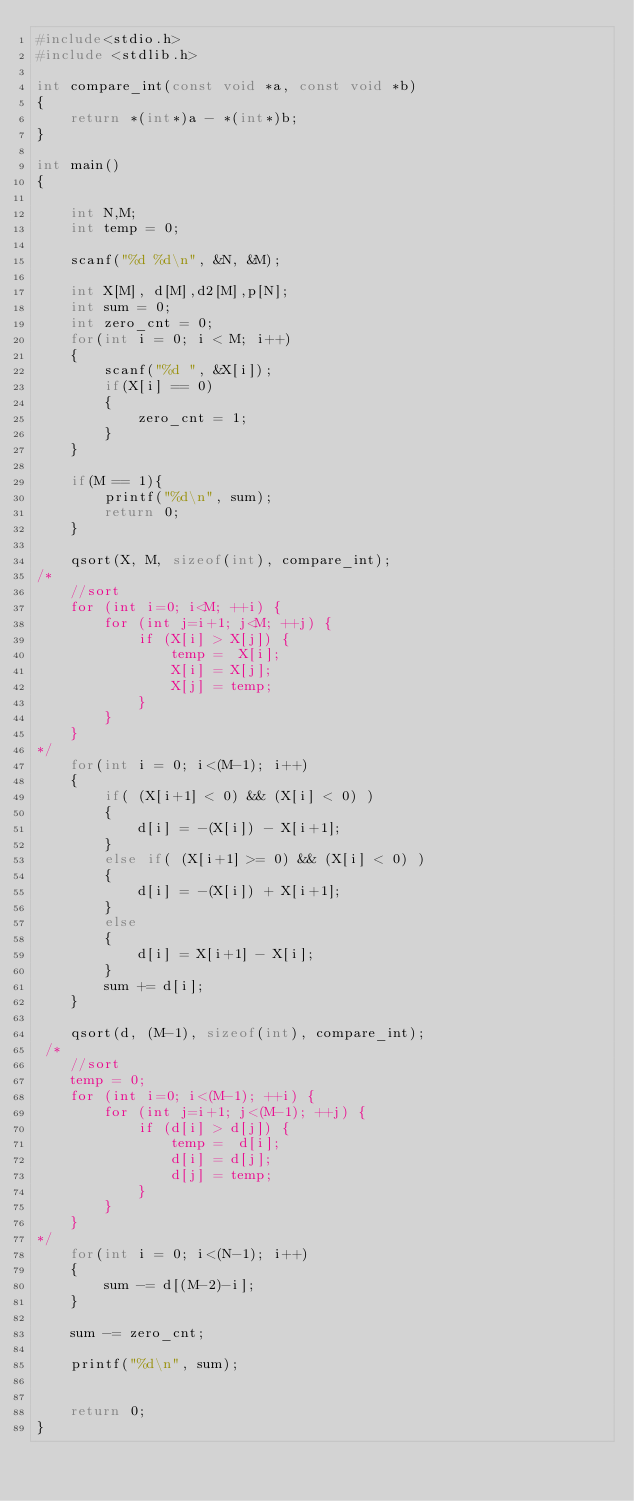<code> <loc_0><loc_0><loc_500><loc_500><_C_>#include<stdio.h>
#include <stdlib.h>

int compare_int(const void *a, const void *b)
{
    return *(int*)a - *(int*)b;
}

int main()
{

    int N,M;
    int temp = 0;

    scanf("%d %d\n", &N, &M);

    int X[M], d[M],d2[M],p[N];
    int sum = 0;
    int zero_cnt = 0;
    for(int i = 0; i < M; i++)
    {
        scanf("%d ", &X[i]);
        if(X[i] == 0)
        {
            zero_cnt = 1;
        }
    }

    if(M == 1){
        printf("%d\n", sum);
        return 0;
    }

    qsort(X, M, sizeof(int), compare_int);
/*
    //sort
    for (int i=0; i<M; ++i) {
        for (int j=i+1; j<M; ++j) {
            if (X[i] > X[j]) {
                temp =  X[i];
                X[i] = X[j];
                X[j] = temp;
            }
        }
    }
*/
    for(int i = 0; i<(M-1); i++)
    {
        if( (X[i+1] < 0) && (X[i] < 0) )
        {
            d[i] = -(X[i]) - X[i+1];
        }
        else if( (X[i+1] >= 0) && (X[i] < 0) )
        {
            d[i] = -(X[i]) + X[i+1];
        }
        else
        {
            d[i] = X[i+1] - X[i];
        }
        sum += d[i];        
    }

    qsort(d, (M-1), sizeof(int), compare_int);
 /*   
    //sort
    temp = 0;
    for (int i=0; i<(M-1); ++i) {
        for (int j=i+1; j<(M-1); ++j) {
            if (d[i] > d[j]) {
                temp =  d[i];
                d[i] = d[j];
                d[j] = temp;
            }
        }
    }
*/
    for(int i = 0; i<(N-1); i++)
    {
        sum -= d[(M-2)-i];
    }

    sum -= zero_cnt;

    printf("%d\n", sum);


    return 0;
}
</code> 